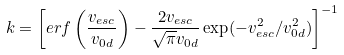<formula> <loc_0><loc_0><loc_500><loc_500>k = \left [ e r f \left ( \frac { v _ { e s c } } { v _ { 0 d } } \right ) - \frac { 2 v _ { e s c } } { \sqrt { \pi } v _ { 0 d } } \exp ( - v _ { e s c } ^ { 2 } / v _ { 0 d } ^ { 2 } ) \right ] ^ { - 1 }</formula> 